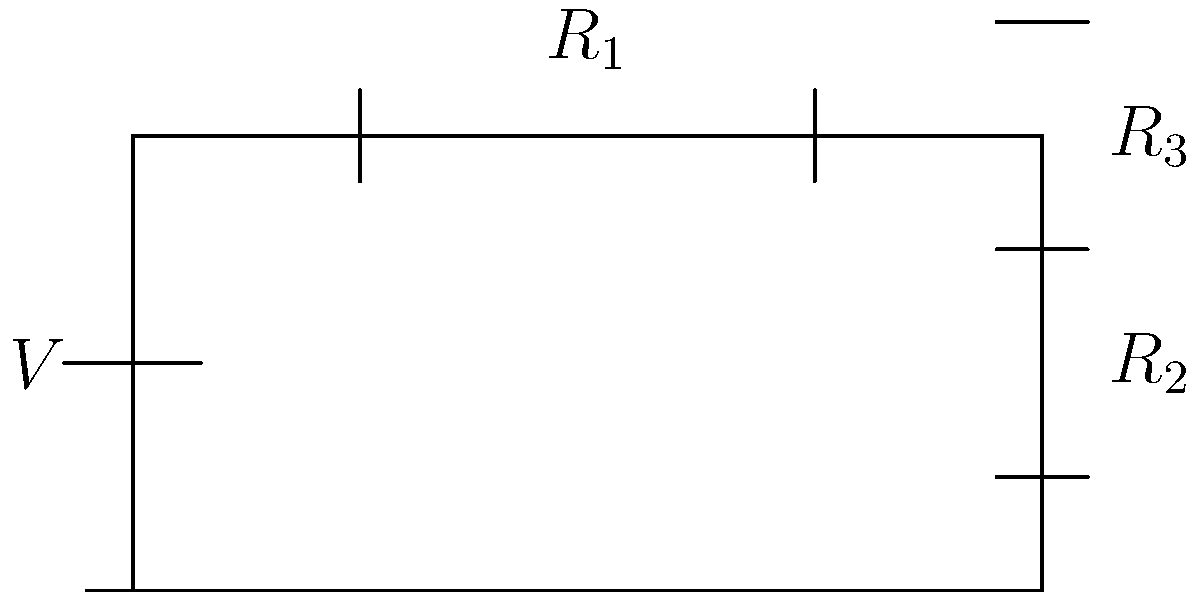As a school principal looking to improve test scores, you're reviewing the physics curriculum. You come across a circuit diagram with a voltage source $V$ and three resistors $R_1$, $R_2$, and $R_3$. $R_1$ is in series with the parallel combination of $R_2$ and $R_3$. If $V = 12$ V, $R_1 = 2$ Ω, $R_2 = 6$ Ω, and $R_3 = 3$ Ω, what is the total current flowing through the circuit? To find the total current, we need to calculate the total resistance of the circuit and then use Ohm's law. Let's break it down step-by-step:

1) First, calculate the equivalent resistance of the parallel combination of $R_2$ and $R_3$:
   $$\frac{1}{R_{eq}} = \frac{1}{R_2} + \frac{1}{R_3} = \frac{1}{6} + \frac{1}{3} = \frac{1}{2}$$
   $$R_{eq} = 2 \text{ Ω}$$

2) Now, add this equivalent resistance to $R_1$ (they're in series):
   $$R_{total} = R_1 + R_{eq} = 2 + 2 = 4 \text{ Ω}$$

3) Use Ohm's law to calculate the total current:
   $$I = \frac{V}{R_{total}} = \frac{12}{4} = 3 \text{ A}$$

Therefore, the total current flowing through the circuit is 3 amperes.
Answer: 3 A 